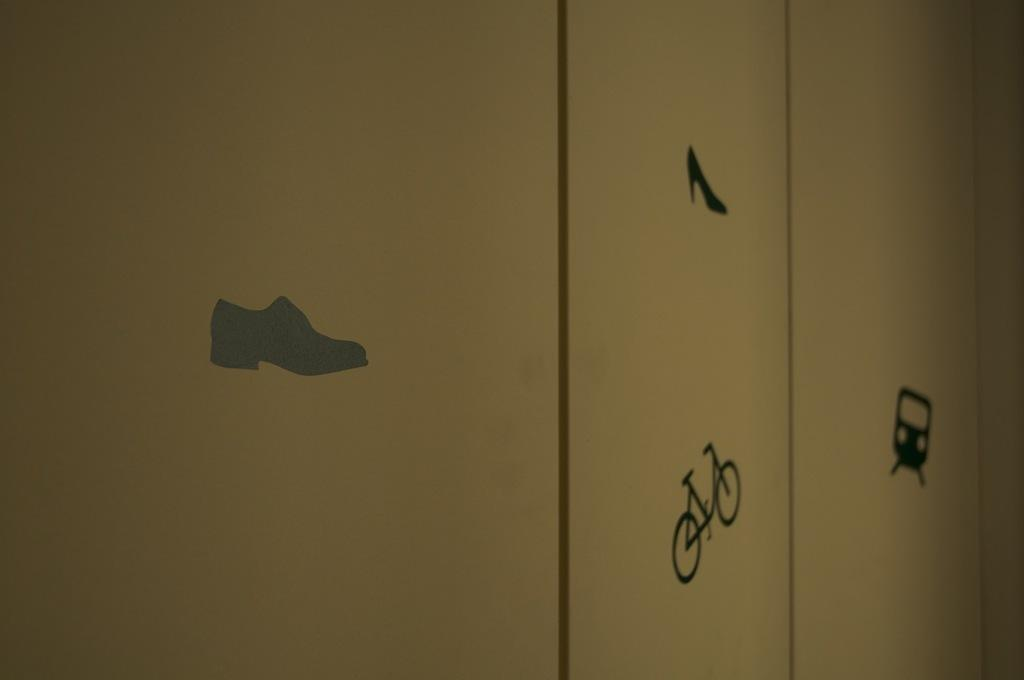What is the main object in the center of the image? There is a cupboard in the center of the image. What decorations are on the cupboard? There are stickers of aers of a train, a bicycle, and a shoe on the cupboard. Can you tell me how many zephyrs are flying around the cupboard in the image? There are no zephyrs present in the image, as a zephyr is a gentle breeze and not a visible object. 